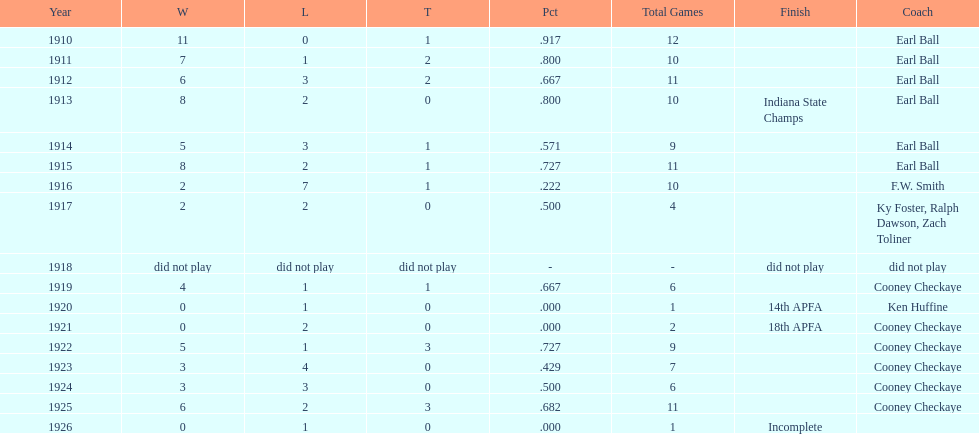Who coached the muncie flyers to an indiana state championship? Earl Ball. 